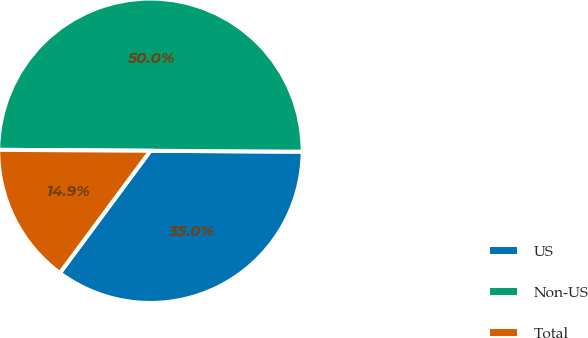<chart> <loc_0><loc_0><loc_500><loc_500><pie_chart><fcel>US<fcel>Non-US<fcel>Total<nl><fcel>35.05%<fcel>50.0%<fcel>14.95%<nl></chart> 